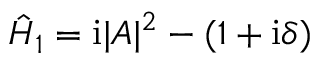<formula> <loc_0><loc_0><loc_500><loc_500>\hat { H } _ { 1 } = i | A | ^ { 2 } - ( 1 + i \delta )</formula> 